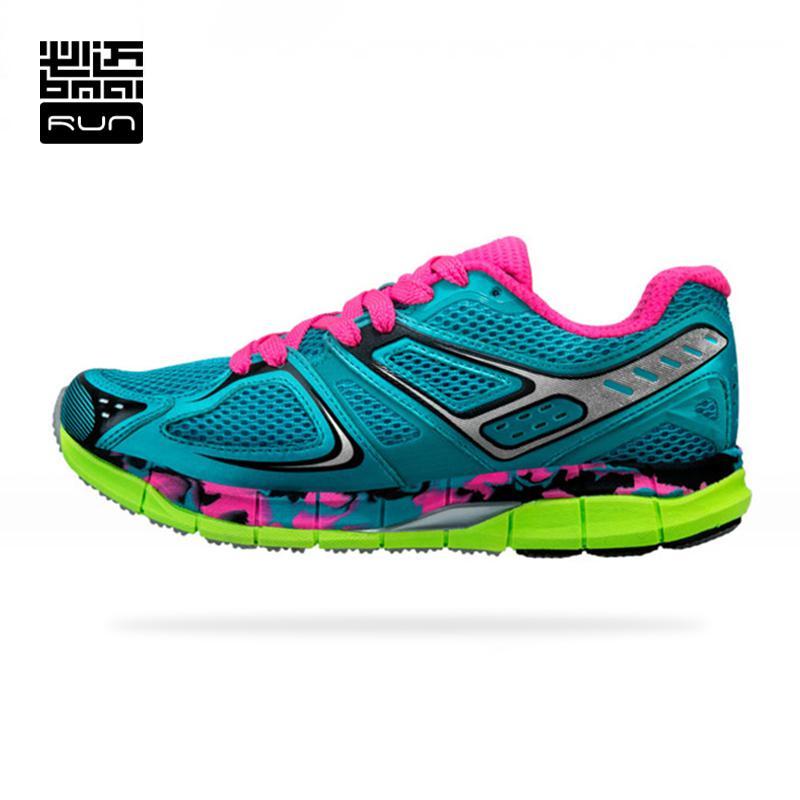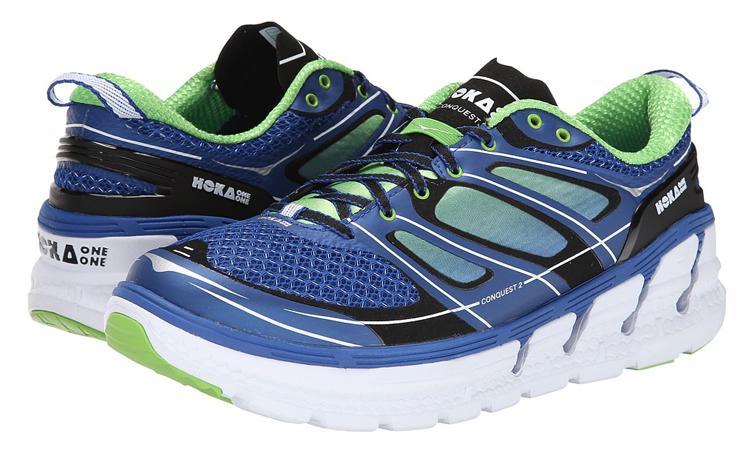The first image is the image on the left, the second image is the image on the right. For the images displayed, is the sentence "In one image, a shoe featuring turquise, gray, and lime green is laced with turquoise colored strings, and is positioned so the toe section is angled towards the front." factually correct? Answer yes or no. No. The first image is the image on the left, the second image is the image on the right. Given the left and right images, does the statement "Each image contains a single sneaker, and the sneakers in the right and left images face the same direction." hold true? Answer yes or no. No. 